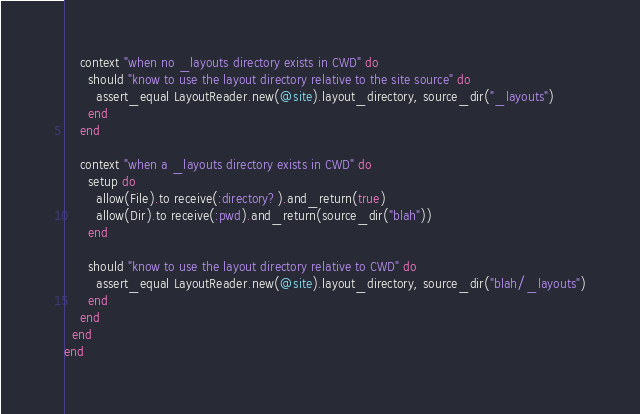<code> <loc_0><loc_0><loc_500><loc_500><_Ruby_>
    context "when no _layouts directory exists in CWD" do
      should "know to use the layout directory relative to the site source" do
        assert_equal LayoutReader.new(@site).layout_directory, source_dir("_layouts")
      end
    end

    context "when a _layouts directory exists in CWD" do
      setup do
        allow(File).to receive(:directory?).and_return(true)
        allow(Dir).to receive(:pwd).and_return(source_dir("blah"))
      end

      should "know to use the layout directory relative to CWD" do
        assert_equal LayoutReader.new(@site).layout_directory, source_dir("blah/_layouts")
      end
    end
  end
end
</code> 